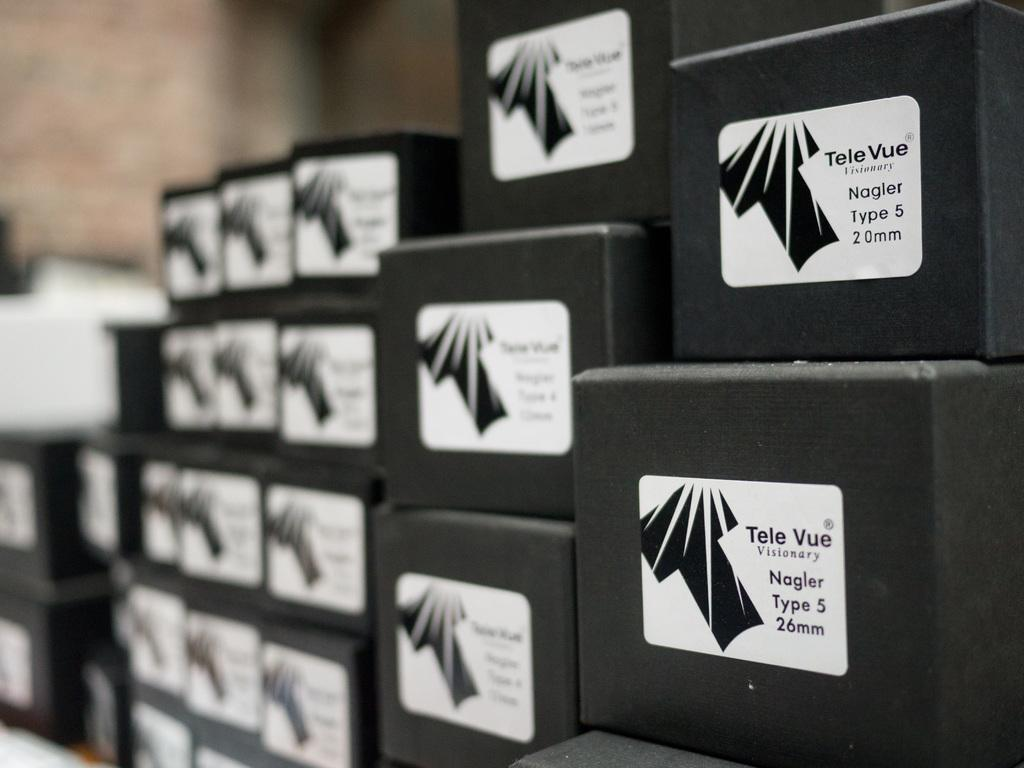<image>
Provide a brief description of the given image. A lot of black boxes with stickers on them that say Tele Vue. 